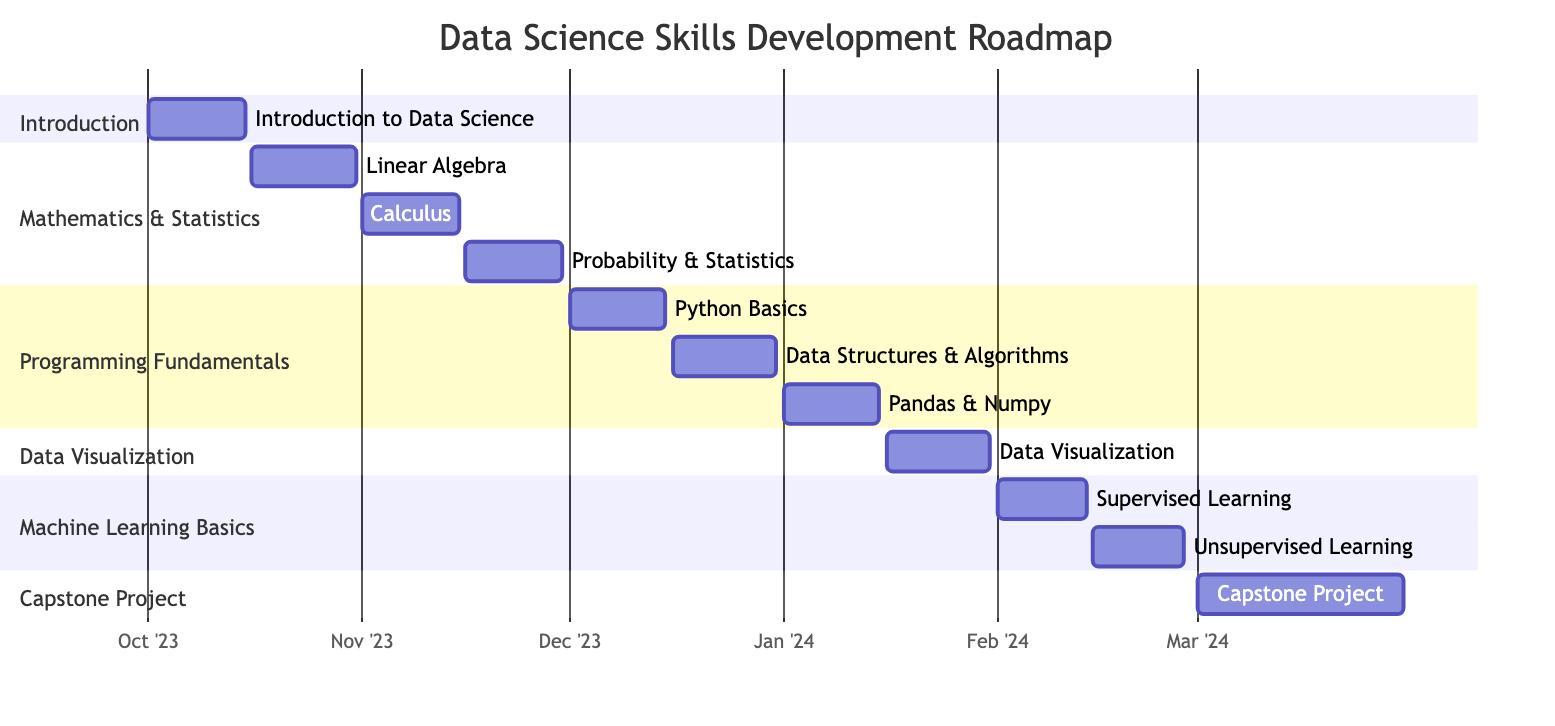What is the duration of the "Introduction to Data Science" task? The task "Introduction to Data Science" starts on October 1, 2023, and ends on October 15, 2023. To find the duration, we count the number of days from the start date to the end date, which is 15 days.
Answer: 15 days How many subtasks are under "Mathematics & Statistics"? The "Mathematics & Statistics" task has three subtasks: "Linear Algebra," "Calculus," and "Probability & Statistics." This counts as three subtasks.
Answer: 3 What is the start date of "Data Visualization"? The "Data Visualization" task starts on January 16, 2024, specifically mentioned in the Gantt chart section.
Answer: January 16, 2024 What is the relationship between "Machine Learning Basics" and "Data Visualization"? "Machine Learning Basics" is dependent on the completion of "Data Visualization." This means that "Data Visualization" must be finished before starting "Machine Learning Basics."
Answer: Dependent What is the total duration of tasks in the "Programming Fundamentals" section? The section "Programming Fundamentals" consists of three tasks, with durations of 15 days (Python Basics), 15 days (Data Structures & Algorithms), and 15 days (Pandas & Numpy). Therefore, the total duration is 15 + 15 + 15 = 45 days.
Answer: 45 days When does the "Capstone Project" start? The "Capstone Project" starts on March 1, 2024, as specified in the Gantt chart.
Answer: March 1, 2024 How many total tasks are represented in the diagram? There are six main tasks: "Introduction to Data Science," "Mathematics & Statistics," "Programming Fundamentals," "Data Visualization," "Machine Learning Basics," and "Capstone Project." Thus, the total number of tasks is six.
Answer: 6 Which task follows "Data Visualization" chronologically? The task that follows "Data Visualization" is "Machine Learning Basics," which starts the day after "Data Visualization" ends, i.e., on February 1, 2024.
Answer: Machine Learning Basics What are the two main components of "Machine Learning Basics"? "Machine Learning Basics" consists of two components: "Supervised Learning" and "Unsupervised Learning," clearly outlined in the Gantt chart under this task.
Answer: Supervised Learning and Unsupervised Learning 